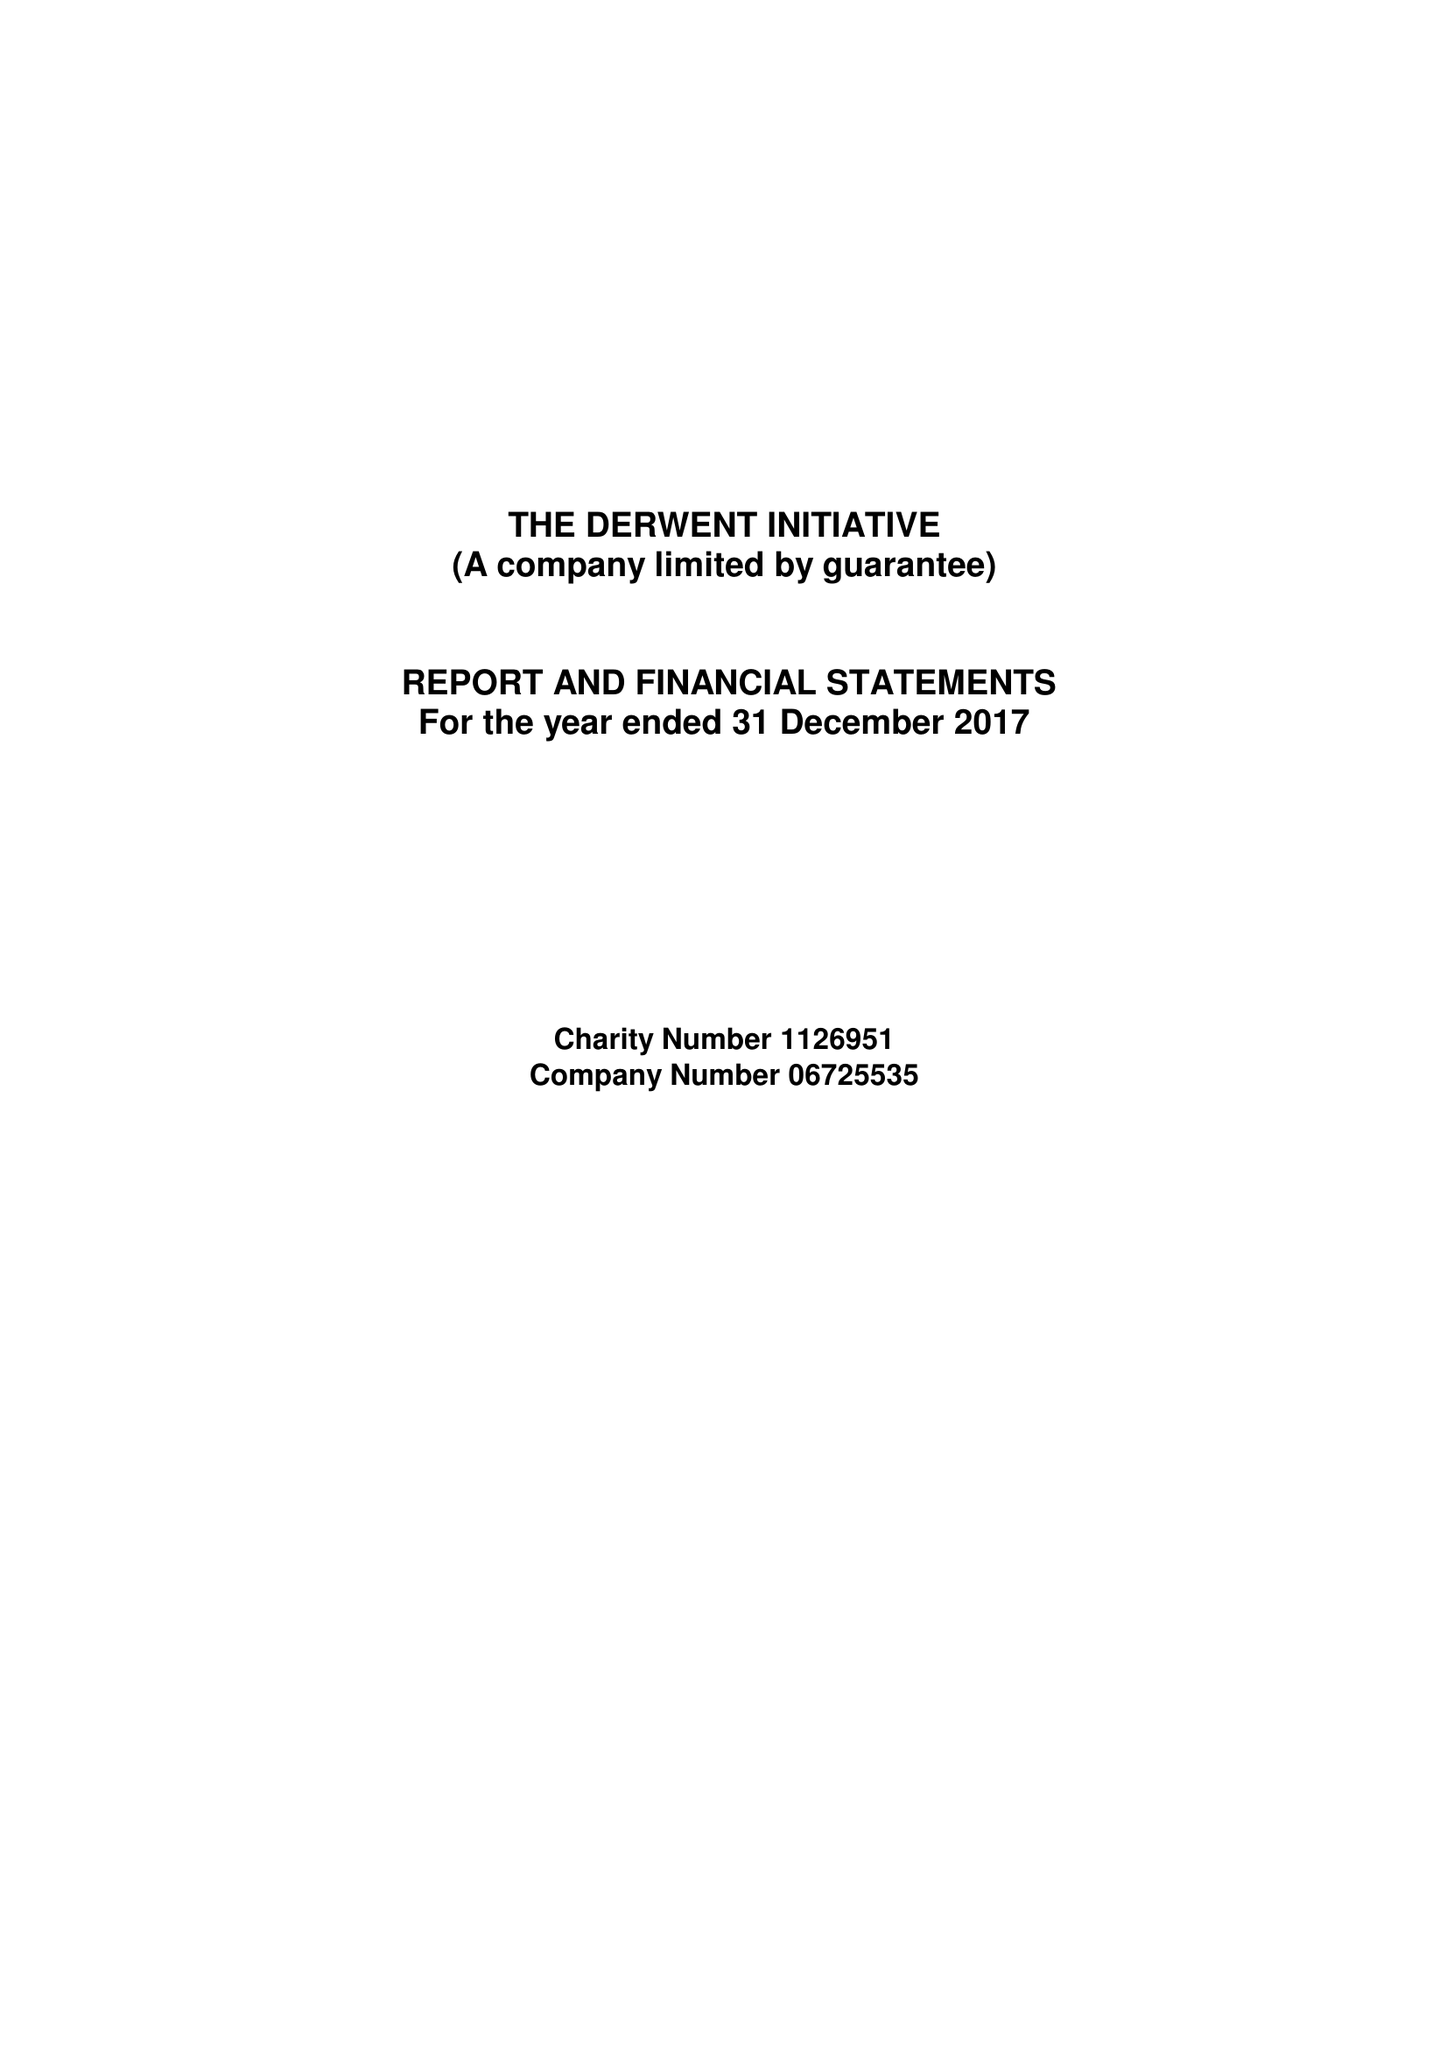What is the value for the report_date?
Answer the question using a single word or phrase. 2017-12-31 